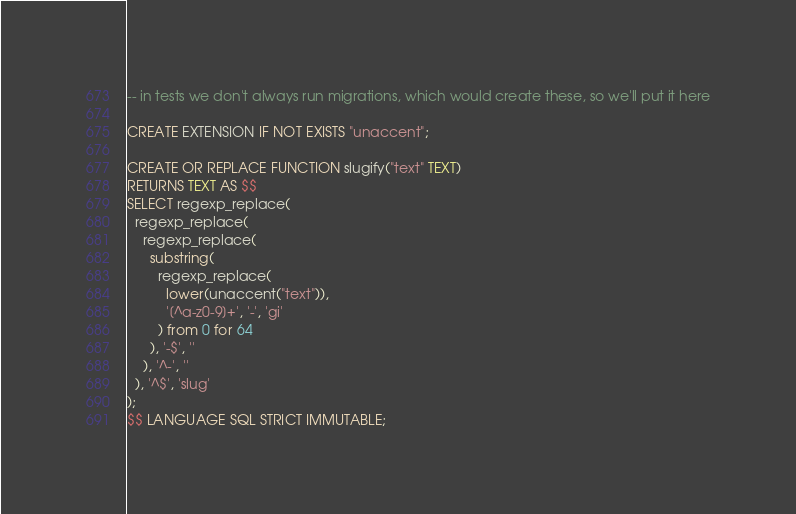Convert code to text. <code><loc_0><loc_0><loc_500><loc_500><_SQL_>-- in tests we don't always run migrations, which would create these, so we'll put it here

CREATE EXTENSION IF NOT EXISTS "unaccent";

CREATE OR REPLACE FUNCTION slugify("text" TEXT)
RETURNS TEXT AS $$
SELECT regexp_replace(
  regexp_replace(
    regexp_replace(
      substring(
        regexp_replace(
          lower(unaccent("text")),
          '[^a-z0-9]+', '-', 'gi'
        ) from 0 for 64
      ), '-$', ''
    ), '^-', ''
  ), '^$', 'slug'
);
$$ LANGUAGE SQL STRICT IMMUTABLE;
</code> 